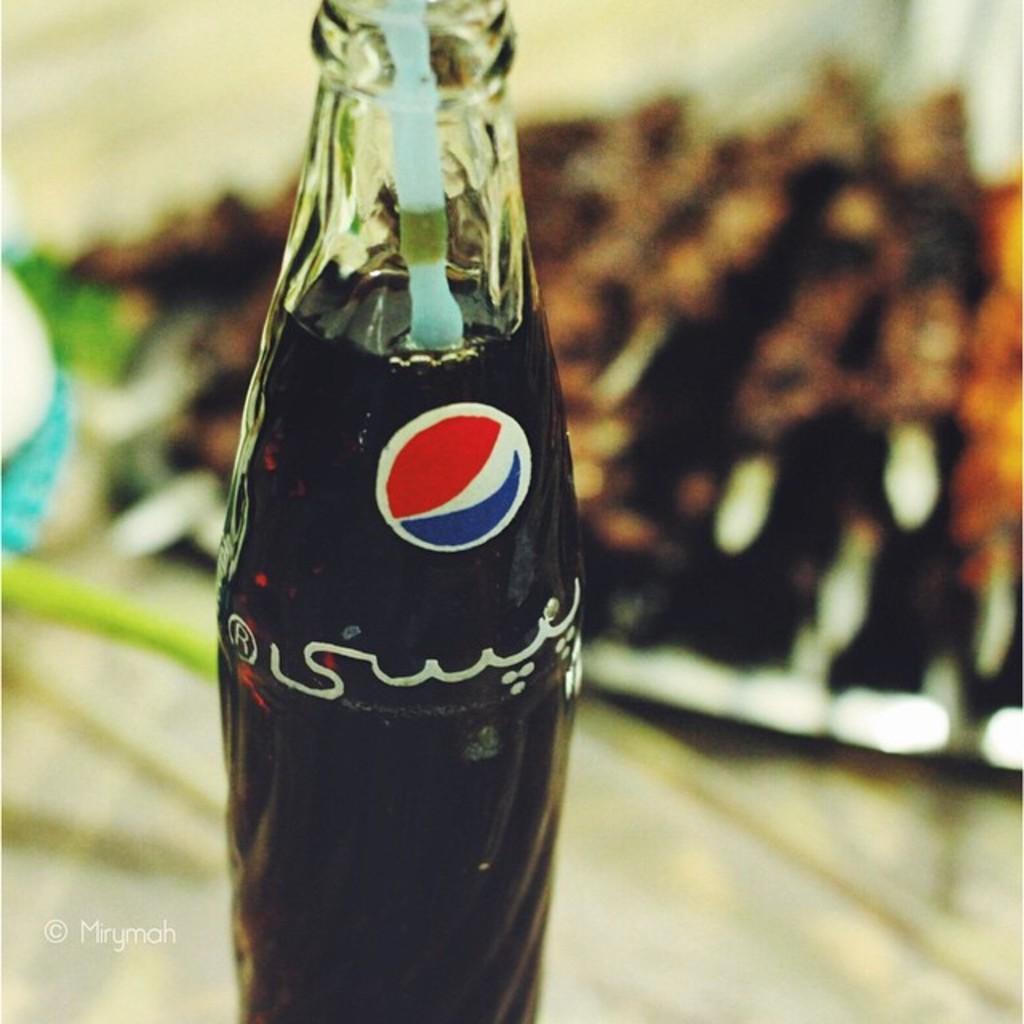Describe this image in one or two sentences. In this picture we can see a bottle with full of drink. 